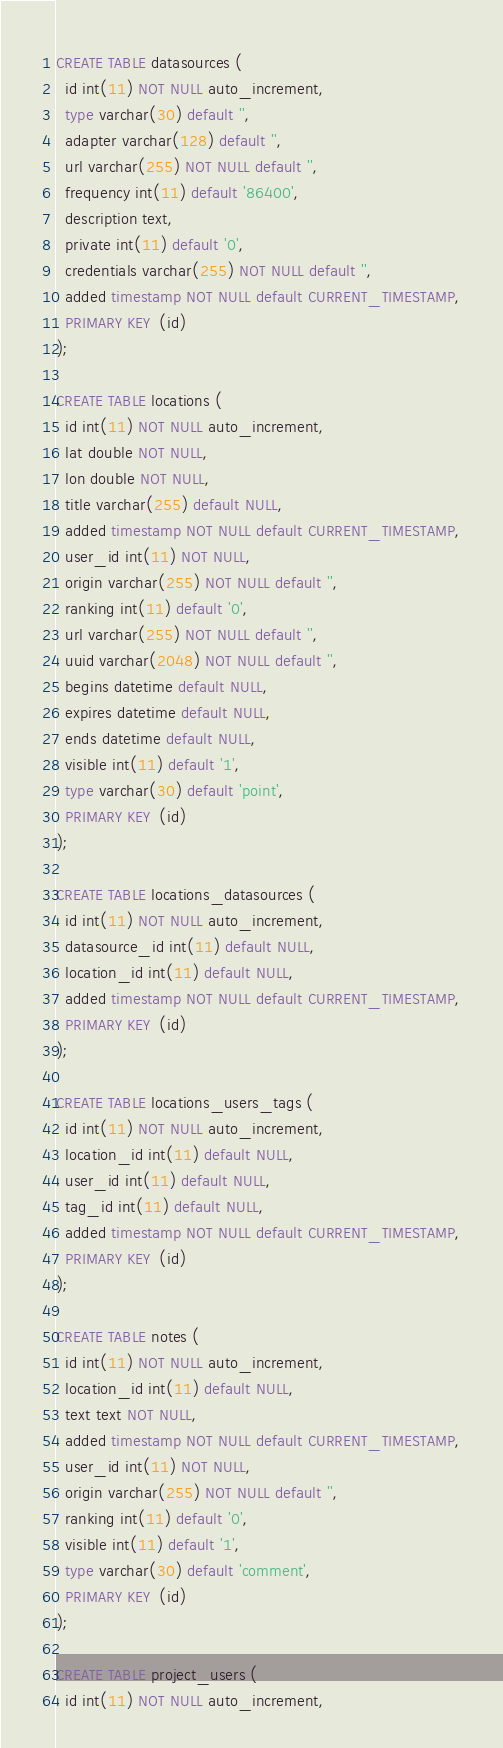Convert code to text. <code><loc_0><loc_0><loc_500><loc_500><_SQL_>CREATE TABLE datasources (
  id int(11) NOT NULL auto_increment,
  type varchar(30) default '',
  adapter varchar(128) default '',
  url varchar(255) NOT NULL default '',
  frequency int(11) default '86400',
  description text,
  private int(11) default '0',
  credentials varchar(255) NOT NULL default '',
  added timestamp NOT NULL default CURRENT_TIMESTAMP,
  PRIMARY KEY  (id)
);

CREATE TABLE locations (
  id int(11) NOT NULL auto_increment,
  lat double NOT NULL,
  lon double NOT NULL,
  title varchar(255) default NULL,
  added timestamp NOT NULL default CURRENT_TIMESTAMP,
  user_id int(11) NOT NULL,
  origin varchar(255) NOT NULL default '',
  ranking int(11) default '0',
  url varchar(255) NOT NULL default '',
  uuid varchar(2048) NOT NULL default '',
  begins datetime default NULL,
  expires datetime default NULL,
  ends datetime default NULL,
  visible int(11) default '1',
  type varchar(30) default 'point',
  PRIMARY KEY  (id)
); 

CREATE TABLE locations_datasources (
  id int(11) NOT NULL auto_increment,
  datasource_id int(11) default NULL,
  location_id int(11) default NULL,
  added timestamp NOT NULL default CURRENT_TIMESTAMP,
  PRIMARY KEY  (id)
);

CREATE TABLE locations_users_tags (
  id int(11) NOT NULL auto_increment,
  location_id int(11) default NULL,
  user_id int(11) default NULL,
  tag_id int(11) default NULL,
  added timestamp NOT NULL default CURRENT_TIMESTAMP,
  PRIMARY KEY  (id)
);

CREATE TABLE notes (
  id int(11) NOT NULL auto_increment,
  location_id int(11) default NULL,
  text text NOT NULL,
  added timestamp NOT NULL default CURRENT_TIMESTAMP,
  user_id int(11) NOT NULL,
  origin varchar(255) NOT NULL default '',
  ranking int(11) default '0',
  visible int(11) default '1',
  type varchar(30) default 'comment',
  PRIMARY KEY  (id)
);

CREATE TABLE project_users (
  id int(11) NOT NULL auto_increment,</code> 